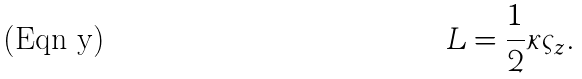Convert formula to latex. <formula><loc_0><loc_0><loc_500><loc_500>L = \frac { 1 } { 2 } \kappa \varsigma _ { z } .</formula> 